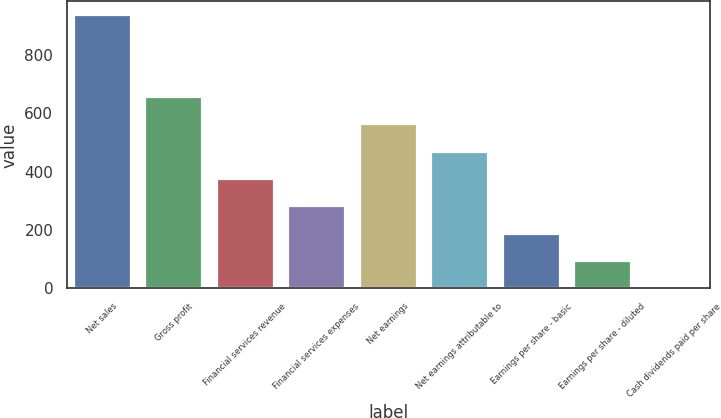Convert chart to OTSL. <chart><loc_0><loc_0><loc_500><loc_500><bar_chart><fcel>Net sales<fcel>Gross profit<fcel>Financial services revenue<fcel>Financial services expenses<fcel>Net earnings<fcel>Net earnings attributable to<fcel>Earnings per share - basic<fcel>Earnings per share - diluted<fcel>Cash dividends paid per share<nl><fcel>935.5<fcel>655.11<fcel>374.7<fcel>281.23<fcel>561.64<fcel>468.17<fcel>187.76<fcel>94.29<fcel>0.82<nl></chart> 